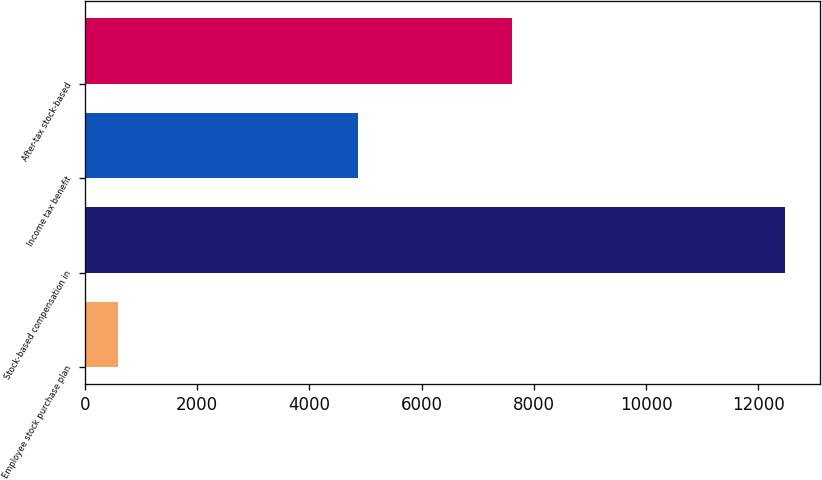<chart> <loc_0><loc_0><loc_500><loc_500><bar_chart><fcel>Employee stock purchase plan<fcel>Stock-based compensation in<fcel>Income tax benefit<fcel>After-tax stock-based<nl><fcel>586<fcel>12474<fcel>4865<fcel>7609<nl></chart> 